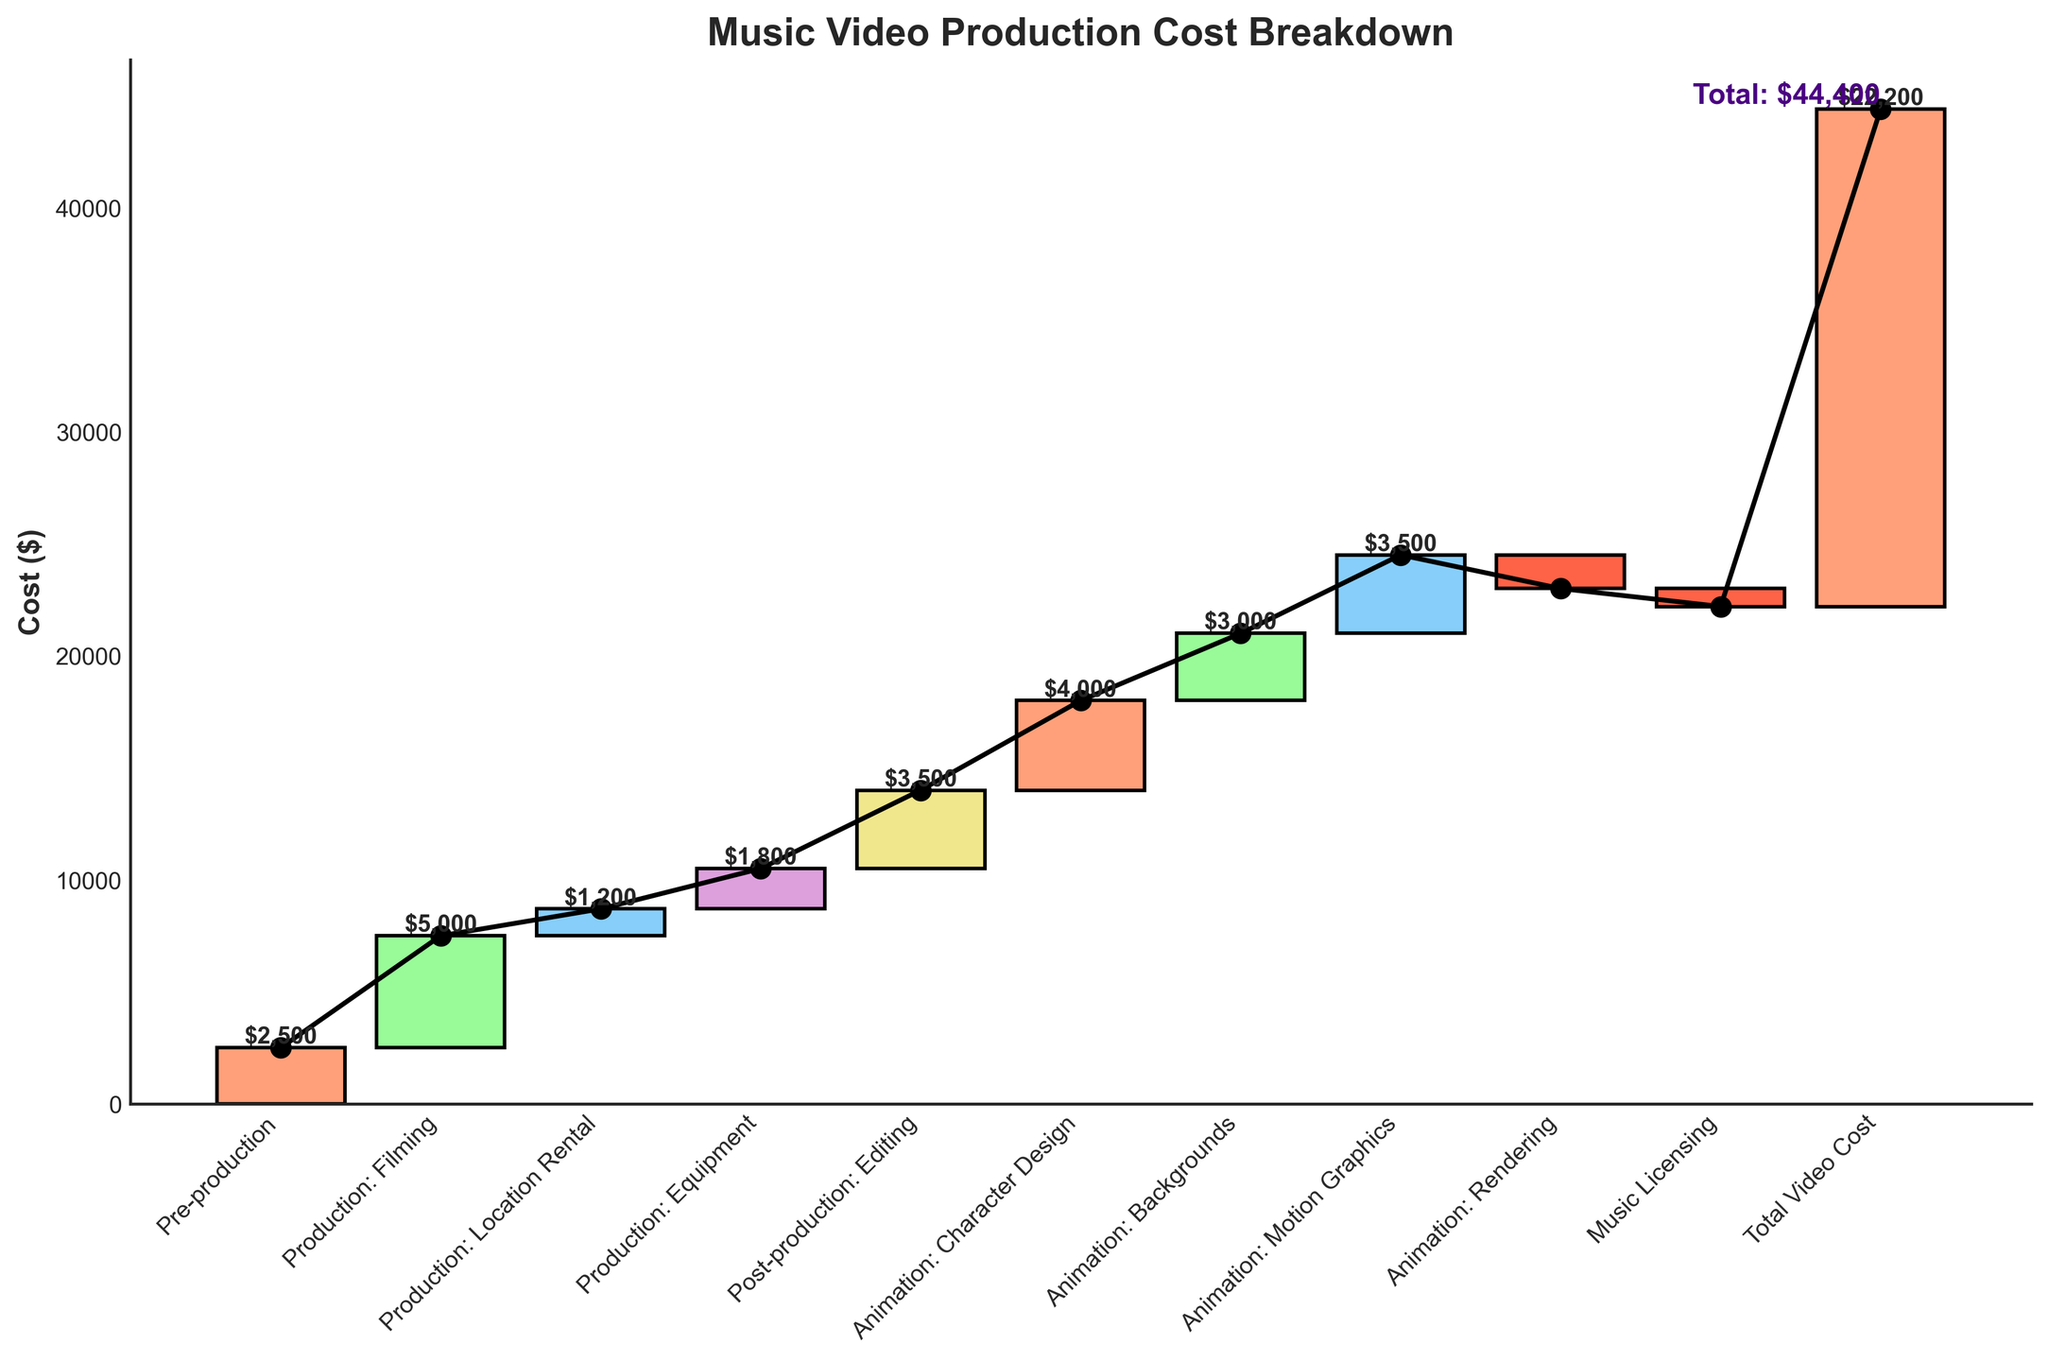How much does the pre-production phase cost? From the chart, the pre-production phase has a single bar labeled "Pre-production" with a value attached to it. This value represents the cost of the pre-production phase.
Answer: $2,500 What is the total cost of the animation phase? The animation phase includes multiple components: Character Design, Backgrounds, Motion Graphics, and Rendering. To find the total cost, sum the values of these components. The costs are $4,000 (Character Design) + $3,000 (Backgrounds) + $3,500 (Motion Graphics) - $1,500 (Rendering) = $9,000.
Answer: $9,000 What is the highest expense category, and how much is it? By examining the chart, the highest bar represents the Production: Filming category, and the value associated with it is the highest among all categories.
Answer: Production: Filming, $5,000 Which expense category contributes a negative value, and what is its impact? The chart shows bars going below zero for negative values. The categories "Animation: Rendering" and "Music Licensing" have negative values. "Animation: Rendering" impacts the total by decreasing it by $1,500, and "Music Licensing" decreases it by $800.
Answer: Animation: Rendering impacts $1,500 and Music Licensing impacts $800 What is the total post-production cost? The post-production phase includes the Editing category. Summing the value of post-production (Editing) gives $3,500.
Answer: $3,500 What is the difference in cost between Production: Equipment and Animation: Backgrounds? The Production: Equipment has a cost of $1,800, and Animation: Backgrounds has a cost of $3,000. The difference is $3,000 - $1,800 = $1,200.
Answer: $1,200 Which category has the lowest positive expenditure, and what is its amount? By comparing the positive values in the chart, the category with the smallest positive expenditure is "Production: Location Rental," with a cost of $1,200.
Answer: Production: Location Rental, $1,200 How does the cumulative cost change after adding the Animation: Motion Graphics cost? Before adding the Animation: Motion Graphics cost, the cumulative cost can be derived by sequentially adding the previous components. Animation: Motion Graphics has a cost of $3,500. Adding it to the preceding cumulative total (which is $15,700 before "Animation: Motion Graphics") yields a new cumulative total of $19,200.
Answer: $19,200 What are the total expenses for all production categories combined (Filming, Location Rental, and Equipment)? To find the total production cost, sum the values of these three categories: $5,000 (Filming) + $1,200 (Location Rental) + $1,800 (Equipment) = $8,000.
Answer: $8,000 What is the net change after considering Animation: Rendering and Music Licensing? The net change is the sum of the negative values provided by Animation: Rendering and Music Licensing: -$1,500 (Rendering) + -$800 (Music Licensing) = -$2,300.
Answer: -$2,300 